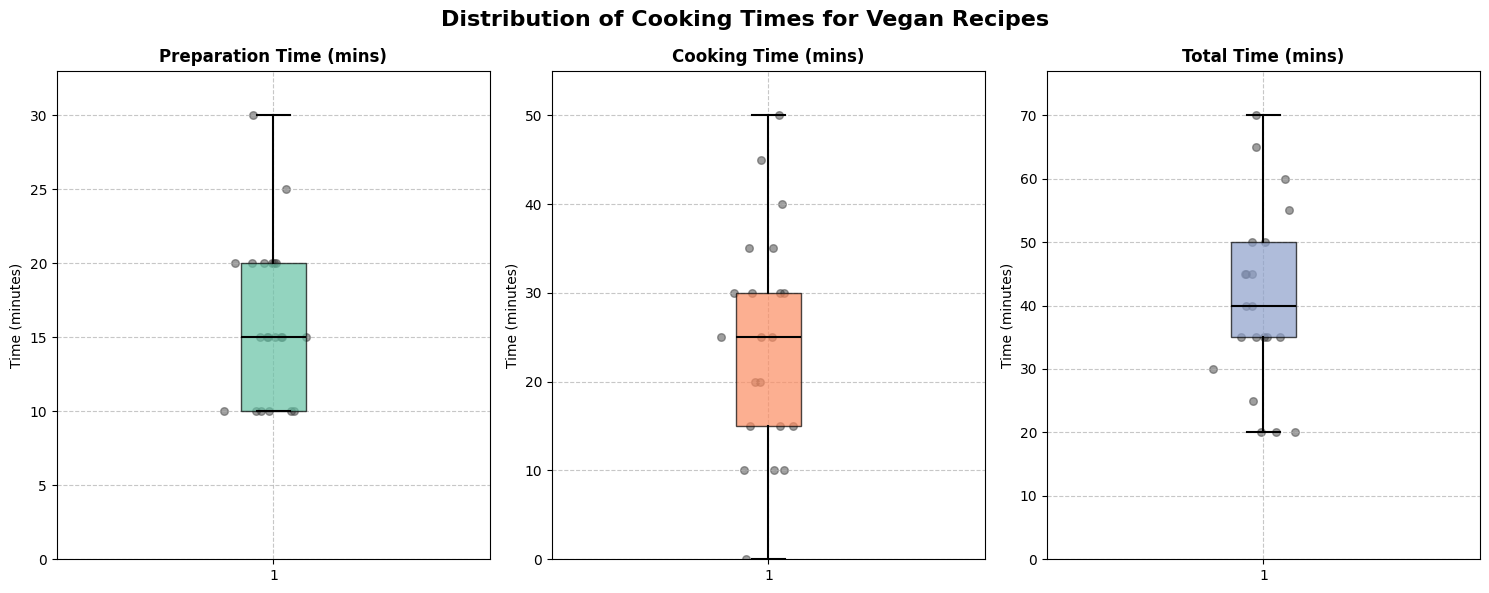What is the title of the figure? The title indicates the purpose of the figure by summarizing the main topic or data presented. The title is located at the top of the figure.
Answer: Distribution of Cooking Times for Vegan Recipes What are the time ranges for Preparation Time, Cooking Time, and Total Time? These ranges are the minimum and maximum values observed in each box plot. They can be inferred by looking at the whiskers of each box plot.
Answer: Preparation Time: 10-30 mins, Cooking Time: 0-50 mins, Total Time: 20-70 mins Which category has the highest median value? To determine this, examine the line inside each box plot which represents the median value of the data.
Answer: Total Time What is the median Cooking Time? The median is indicated by the horizontal line inside the box of the Cooking Time subplot.
Answer: 25 mins How does the spread (interquartile range) of Total Time compare to the spread of Preparation Time? The interquartile range (IQR) is the difference between the upper and lower quartiles (ends of the box). Comparing the lengths of the boxes for Total Time and Preparation Time will reveal the spread.
Answer: Total Time has a wider spread What is the minimum value for Cooking Time? The minimum value is the lowest point of the whisker in the Cooking Time subplot.
Answer: 0 mins Which time category shows the most variability? Variability can be assessed by the length of the box and whiskers in the box plot. The larger the spread of data points (box and whiskers), the higher the variability.
Answer: Total Time What is the total range of values observed for Cooking Time? The range is the difference between the maximum and minimum values. Assess the ends of the whiskers in the Cooking Time box plot.
Answer: 50 mins (0 to 50 mins) Which recipe appears to have the shortest Total Time? This requires identifying any outliers or lowest data points in the Total Time subplot. Look for the lowest point within or outside the whiskers.
Answer: Vegan Sushi Rolls, 30 mins What cooking time categories include a recipe with no cooking? Look for any box plots where the lowest point or one of the data points is at 0 mins.
Answer: Cooking Time 